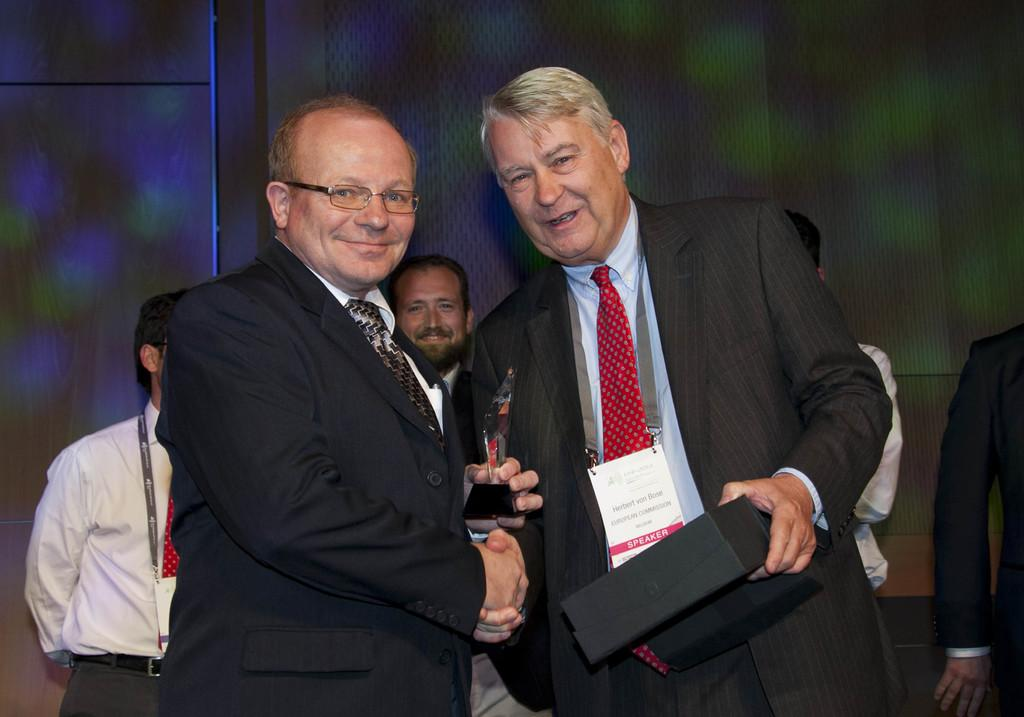How many people are in the image? There are people in the image, but the exact number is not specified. What is the facial expression of the people in the image? The people in the image are smiling. What is one person holding in the image? One person is holding a box. What can be seen in the background of the image? There is a wall in the background of the image. What type of garden can be seen in the image? There is no garden present in the image. Who is the representative of the group in the image? The facts do not mention any group or representative, so it cannot be determined from the image. 